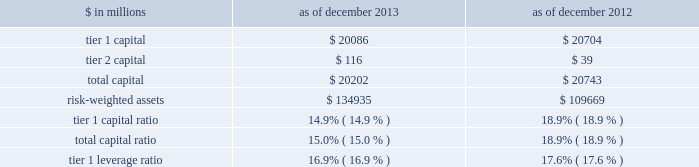Notes to consolidated financial statements under the regulatory framework for prompt corrective action applicable to gs bank usa , in order to meet the quantitative requirements for being a 201cwell-capitalized 201d depository institution , gs bank usa is required to maintain a tier 1 capital ratio of at least 6% ( 6 % ) , a total capital ratio of at least 10% ( 10 % ) and a tier 1 leverage ratio of at least 5% ( 5 % ) .
Gs bank usa agreed with the federal reserve board to maintain minimum capital ratios in excess of these 201cwell- capitalized 201d levels .
Accordingly , for a period of time , gs bank usa is expected to maintain a tier 1 capital ratio of at least 8% ( 8 % ) , a total capital ratio of at least 11% ( 11 % ) and a tier 1 leverage ratio of at least 6% ( 6 % ) .
As noted in the table below , gs bank usa was in compliance with these minimum capital requirements as of december 2013 and december 2012 .
The table below presents information regarding gs bank usa 2019s regulatory capital ratios under basel i , as implemented by the federal reserve board .
The information as of december 2013 reflects the revised market risk regulatory capital requirements , which became effective on january 1 , 2013 .
These changes resulted in increased regulatory capital requirements for market risk .
The information as of december 2012 is prior to the implementation of these revised market risk regulatory capital requirements. .
The revised capital framework described above is also applicable to gs bank usa , which is an advanced approach banking organization under this framework .
Gs bank usa has also been informed by the federal reserve board that it has completed a satisfactory parallel run , as required of advanced approach banking organizations under the revised capital framework , and therefore changes to its calculations of rwas will take effect beginning with the second quarter of 2014 .
Under the revised capital framework , as of january 1 , 2014 , gs bank usa became subject to a new minimum cet1 ratio requirement of 4% ( 4 % ) , increasing to 4.5% ( 4.5 % ) in 2015 .
In addition , the revised capital framework changes the standards for 201cwell-capitalized 201d status under prompt corrective action regulations beginning january 1 , 2015 by , among other things , introducing a cet1 ratio requirement of 6.5% ( 6.5 % ) and increasing the tier 1 capital ratio requirement from 6% ( 6 % ) to 8% ( 8 % ) .
In addition , commencing january 1 , 2018 , advanced approach banking organizations must have a supplementary leverage ratio of 3% ( 3 % ) or greater .
The basel committee published its final guidelines for calculating incremental capital requirements for domestic systemically important banking institutions ( d-sibs ) .
These guidelines are complementary to the framework outlined above for g-sibs .
The impact of these guidelines on the regulatory capital requirements of gs bank usa will depend on how they are implemented by the banking regulators in the united states .
The deposits of gs bank usa are insured by the fdic to the extent provided by law .
The federal reserve board requires depository institutions to maintain cash reserves with a federal reserve bank .
The amount deposited by the firm 2019s depository institution held at the federal reserve bank was approximately $ 50.39 billion and $ 58.67 billion as of december 2013 and december 2012 , respectively , which exceeded required reserve amounts by $ 50.29 billion and $ 58.59 billion as of december 2013 and december 2012 , respectively .
Transactions between gs bank usa and its subsidiaries and group inc .
And its subsidiaries and affiliates ( other than , generally , subsidiaries of gs bank usa ) are regulated by the federal reserve board .
These regulations generally limit the types and amounts of transactions ( including credit extensions from gs bank usa ) that may take place and generally require those transactions to be on market terms or better to gs bank usa .
The firm 2019s principal non-u.s .
Bank subsidiary , gsib , is a wholly-owned credit institution , regulated by the prudential regulation authority ( pra ) and the financial conduct authority ( fca ) and is subject to minimum capital requirements .
As of december 2013 and december 2012 , gsib was in compliance with all regulatory capital requirements .
Goldman sachs 2013 annual report 193 .
If risk-weighted assets held flat how much in millions would tier 1 capital have to decline for the tier 1 capital ratio to reach 8%? 
Computations: (134935 - (134935 * (8% / 100)))
Answer: 134827.052. 